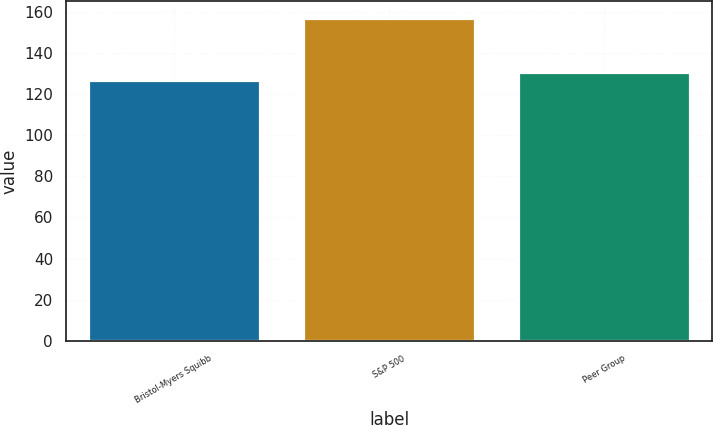<chart> <loc_0><loc_0><loc_500><loc_500><bar_chart><fcel>Bristol-Myers Squibb<fcel>S&P 500<fcel>Peer Group<nl><fcel>126.95<fcel>157.22<fcel>130.89<nl></chart> 